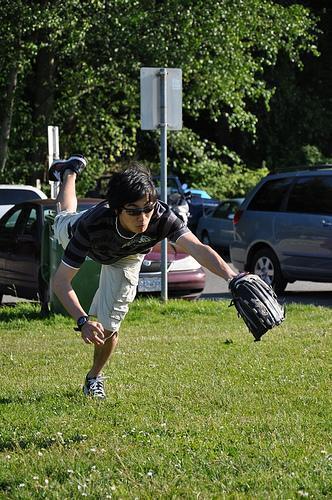What handedness does this person have?
Make your selection from the four choices given to correctly answer the question.
Options: Left, right, none, ambidextrous. Right. 